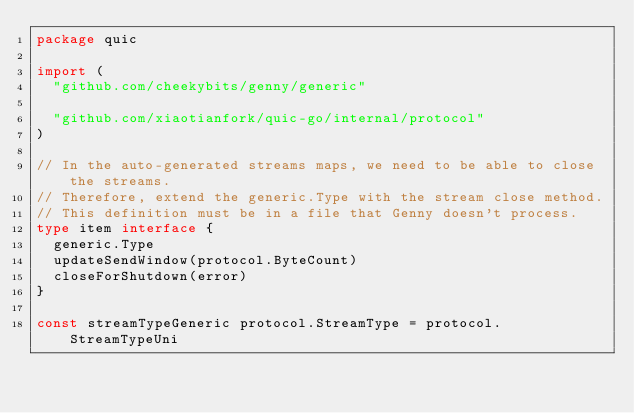Convert code to text. <code><loc_0><loc_0><loc_500><loc_500><_Go_>package quic

import (
	"github.com/cheekybits/genny/generic"

	"github.com/xiaotianfork/quic-go/internal/protocol"
)

// In the auto-generated streams maps, we need to be able to close the streams.
// Therefore, extend the generic.Type with the stream close method.
// This definition must be in a file that Genny doesn't process.
type item interface {
	generic.Type
	updateSendWindow(protocol.ByteCount)
	closeForShutdown(error)
}

const streamTypeGeneric protocol.StreamType = protocol.StreamTypeUni
</code> 